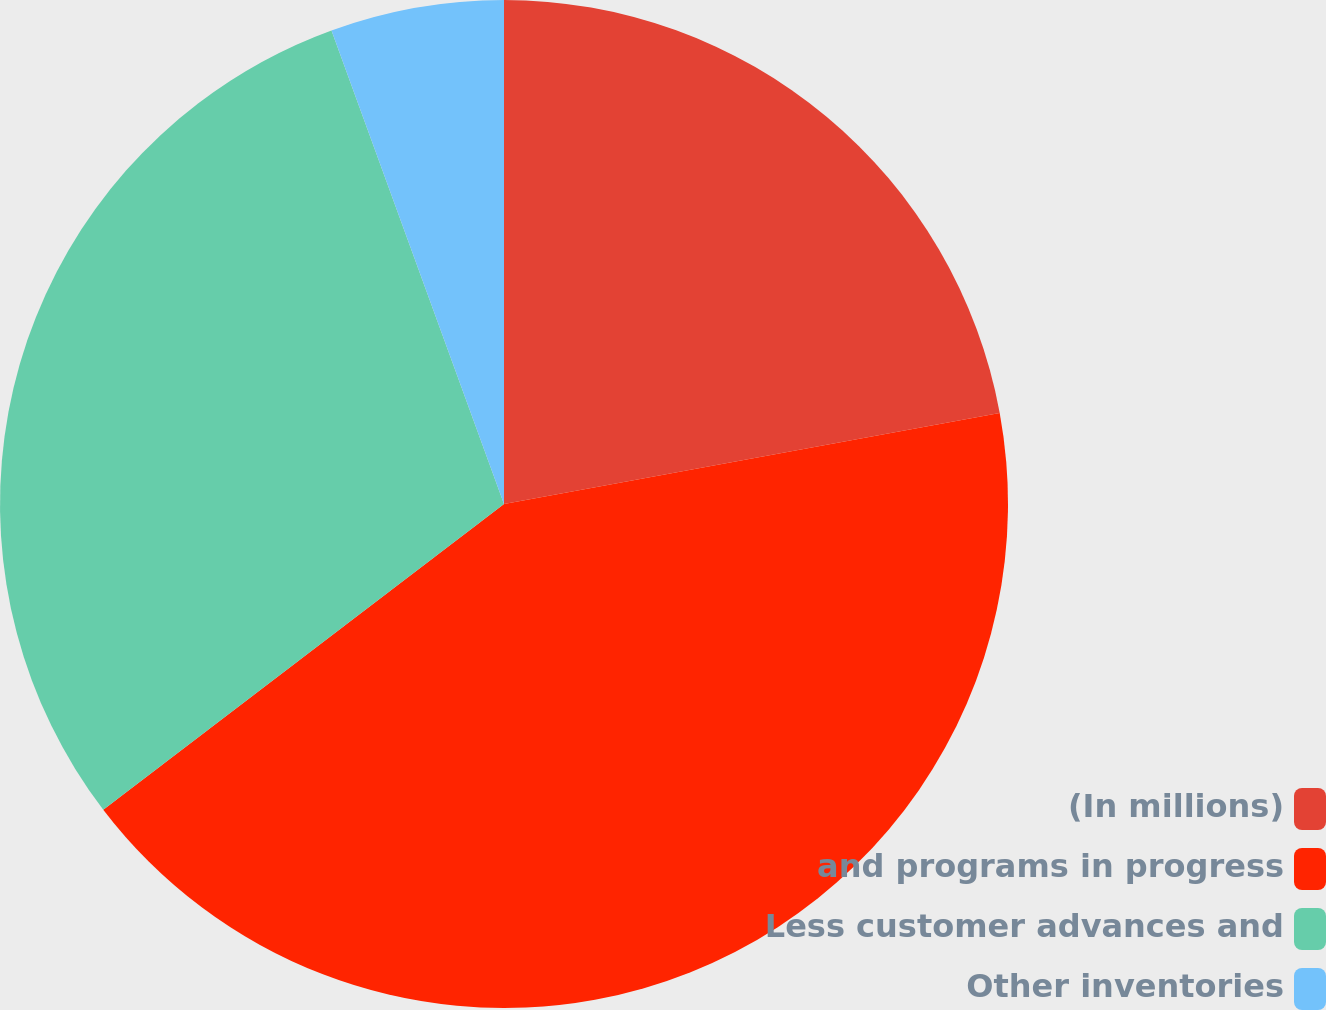Convert chart. <chart><loc_0><loc_0><loc_500><loc_500><pie_chart><fcel>(In millions)<fcel>and programs in progress<fcel>Less customer advances and<fcel>Other inventories<nl><fcel>22.11%<fcel>42.52%<fcel>29.81%<fcel>5.56%<nl></chart> 